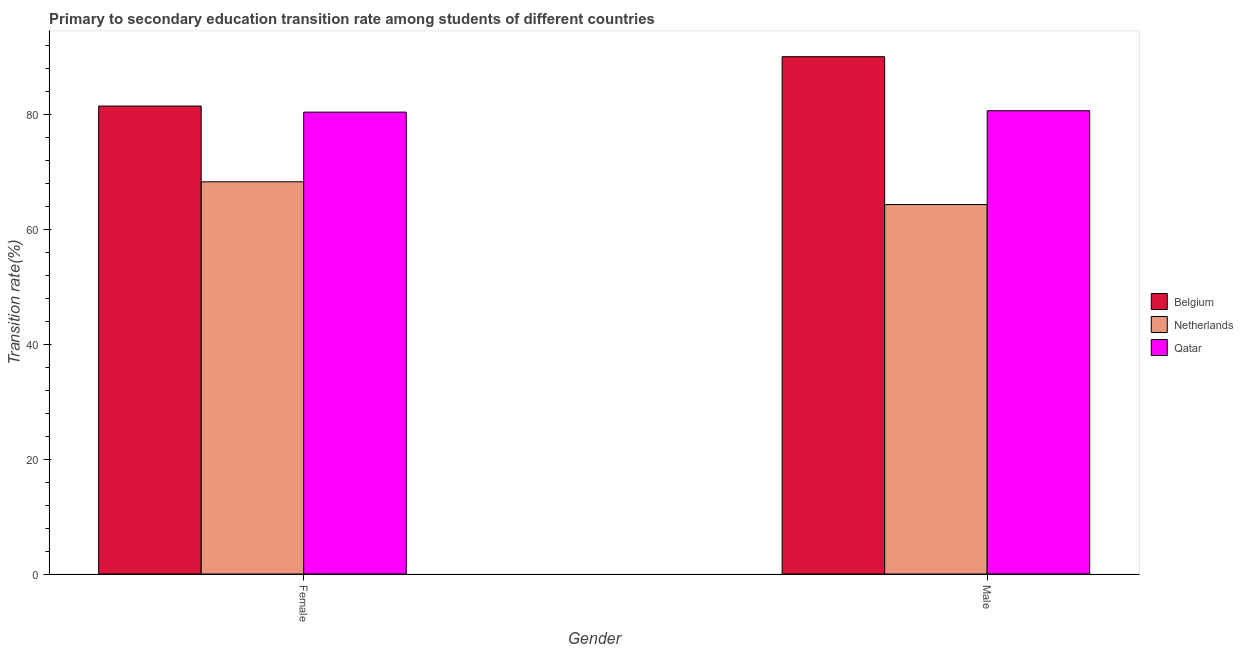How many groups of bars are there?
Your answer should be compact. 2. Are the number of bars on each tick of the X-axis equal?
Offer a very short reply. Yes. How many bars are there on the 1st tick from the left?
Offer a very short reply. 3. What is the label of the 1st group of bars from the left?
Provide a short and direct response. Female. What is the transition rate among female students in Qatar?
Ensure brevity in your answer.  80.33. Across all countries, what is the maximum transition rate among female students?
Give a very brief answer. 81.38. Across all countries, what is the minimum transition rate among male students?
Offer a very short reply. 64.25. What is the total transition rate among female students in the graph?
Make the answer very short. 229.92. What is the difference between the transition rate among female students in Belgium and that in Netherlands?
Your answer should be compact. 13.17. What is the difference between the transition rate among female students in Qatar and the transition rate among male students in Belgium?
Ensure brevity in your answer.  -9.64. What is the average transition rate among female students per country?
Offer a very short reply. 76.64. What is the difference between the transition rate among female students and transition rate among male students in Belgium?
Your response must be concise. -8.59. In how many countries, is the transition rate among female students greater than 52 %?
Your answer should be compact. 3. What is the ratio of the transition rate among female students in Netherlands to that in Qatar?
Your response must be concise. 0.85. Is the transition rate among male students in Qatar less than that in Netherlands?
Make the answer very short. No. In how many countries, is the transition rate among female students greater than the average transition rate among female students taken over all countries?
Keep it short and to the point. 2. What does the 2nd bar from the left in Female represents?
Your answer should be very brief. Netherlands. What does the 1st bar from the right in Female represents?
Make the answer very short. Qatar. Are all the bars in the graph horizontal?
Provide a succinct answer. No. How many countries are there in the graph?
Keep it short and to the point. 3. What is the difference between two consecutive major ticks on the Y-axis?
Keep it short and to the point. 20. Does the graph contain any zero values?
Offer a very short reply. No. Does the graph contain grids?
Your answer should be very brief. No. What is the title of the graph?
Provide a short and direct response. Primary to secondary education transition rate among students of different countries. What is the label or title of the Y-axis?
Provide a succinct answer. Transition rate(%). What is the Transition rate(%) of Belgium in Female?
Provide a succinct answer. 81.38. What is the Transition rate(%) in Netherlands in Female?
Your response must be concise. 68.21. What is the Transition rate(%) of Qatar in Female?
Provide a succinct answer. 80.33. What is the Transition rate(%) in Belgium in Male?
Make the answer very short. 89.97. What is the Transition rate(%) of Netherlands in Male?
Make the answer very short. 64.25. What is the Transition rate(%) in Qatar in Male?
Offer a very short reply. 80.57. Across all Gender, what is the maximum Transition rate(%) in Belgium?
Your answer should be very brief. 89.97. Across all Gender, what is the maximum Transition rate(%) in Netherlands?
Your answer should be very brief. 68.21. Across all Gender, what is the maximum Transition rate(%) in Qatar?
Give a very brief answer. 80.57. Across all Gender, what is the minimum Transition rate(%) in Belgium?
Your answer should be compact. 81.38. Across all Gender, what is the minimum Transition rate(%) in Netherlands?
Offer a very short reply. 64.25. Across all Gender, what is the minimum Transition rate(%) of Qatar?
Keep it short and to the point. 80.33. What is the total Transition rate(%) in Belgium in the graph?
Make the answer very short. 171.35. What is the total Transition rate(%) in Netherlands in the graph?
Make the answer very short. 132.47. What is the total Transition rate(%) in Qatar in the graph?
Offer a terse response. 160.9. What is the difference between the Transition rate(%) of Belgium in Female and that in Male?
Ensure brevity in your answer.  -8.59. What is the difference between the Transition rate(%) of Netherlands in Female and that in Male?
Your answer should be very brief. 3.96. What is the difference between the Transition rate(%) of Qatar in Female and that in Male?
Your response must be concise. -0.24. What is the difference between the Transition rate(%) of Belgium in Female and the Transition rate(%) of Netherlands in Male?
Give a very brief answer. 17.13. What is the difference between the Transition rate(%) of Belgium in Female and the Transition rate(%) of Qatar in Male?
Your response must be concise. 0.82. What is the difference between the Transition rate(%) in Netherlands in Female and the Transition rate(%) in Qatar in Male?
Provide a short and direct response. -12.36. What is the average Transition rate(%) of Belgium per Gender?
Keep it short and to the point. 85.68. What is the average Transition rate(%) in Netherlands per Gender?
Your answer should be very brief. 66.23. What is the average Transition rate(%) of Qatar per Gender?
Provide a short and direct response. 80.45. What is the difference between the Transition rate(%) of Belgium and Transition rate(%) of Netherlands in Female?
Ensure brevity in your answer.  13.17. What is the difference between the Transition rate(%) in Belgium and Transition rate(%) in Qatar in Female?
Offer a terse response. 1.06. What is the difference between the Transition rate(%) of Netherlands and Transition rate(%) of Qatar in Female?
Offer a very short reply. -12.12. What is the difference between the Transition rate(%) in Belgium and Transition rate(%) in Netherlands in Male?
Keep it short and to the point. 25.71. What is the difference between the Transition rate(%) of Belgium and Transition rate(%) of Qatar in Male?
Give a very brief answer. 9.4. What is the difference between the Transition rate(%) in Netherlands and Transition rate(%) in Qatar in Male?
Your answer should be compact. -16.31. What is the ratio of the Transition rate(%) in Belgium in Female to that in Male?
Your answer should be compact. 0.9. What is the ratio of the Transition rate(%) in Netherlands in Female to that in Male?
Give a very brief answer. 1.06. What is the difference between the highest and the second highest Transition rate(%) in Belgium?
Your answer should be very brief. 8.59. What is the difference between the highest and the second highest Transition rate(%) of Netherlands?
Keep it short and to the point. 3.96. What is the difference between the highest and the second highest Transition rate(%) in Qatar?
Provide a short and direct response. 0.24. What is the difference between the highest and the lowest Transition rate(%) of Belgium?
Provide a short and direct response. 8.59. What is the difference between the highest and the lowest Transition rate(%) of Netherlands?
Ensure brevity in your answer.  3.96. What is the difference between the highest and the lowest Transition rate(%) in Qatar?
Keep it short and to the point. 0.24. 